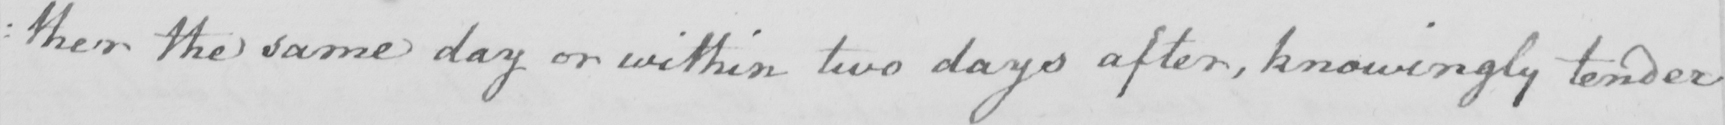What does this handwritten line say? : ther the same day or within two days after , knowing tender 